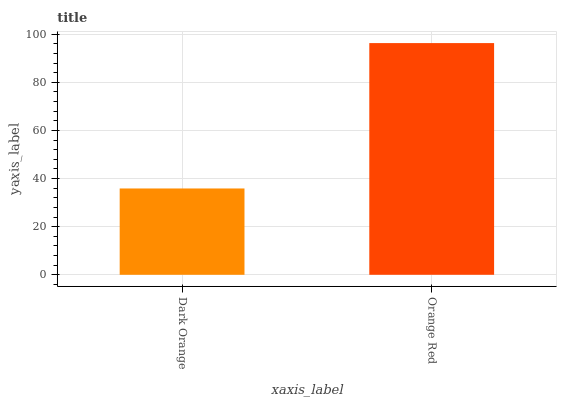Is Orange Red the minimum?
Answer yes or no. No. Is Orange Red greater than Dark Orange?
Answer yes or no. Yes. Is Dark Orange less than Orange Red?
Answer yes or no. Yes. Is Dark Orange greater than Orange Red?
Answer yes or no. No. Is Orange Red less than Dark Orange?
Answer yes or no. No. Is Orange Red the high median?
Answer yes or no. Yes. Is Dark Orange the low median?
Answer yes or no. Yes. Is Dark Orange the high median?
Answer yes or no. No. Is Orange Red the low median?
Answer yes or no. No. 